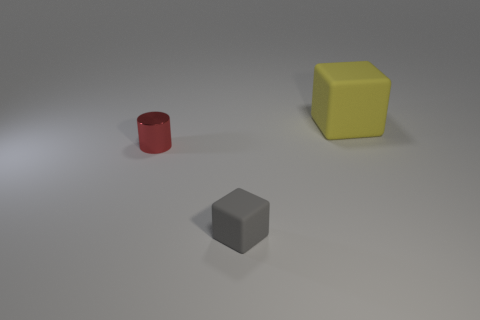Add 3 metallic cylinders. How many objects exist? 6 Subtract all cylinders. How many objects are left? 2 Add 3 small red things. How many small red things are left? 4 Add 1 rubber spheres. How many rubber spheres exist? 1 Subtract 0 cyan cylinders. How many objects are left? 3 Subtract all small metal balls. Subtract all large things. How many objects are left? 2 